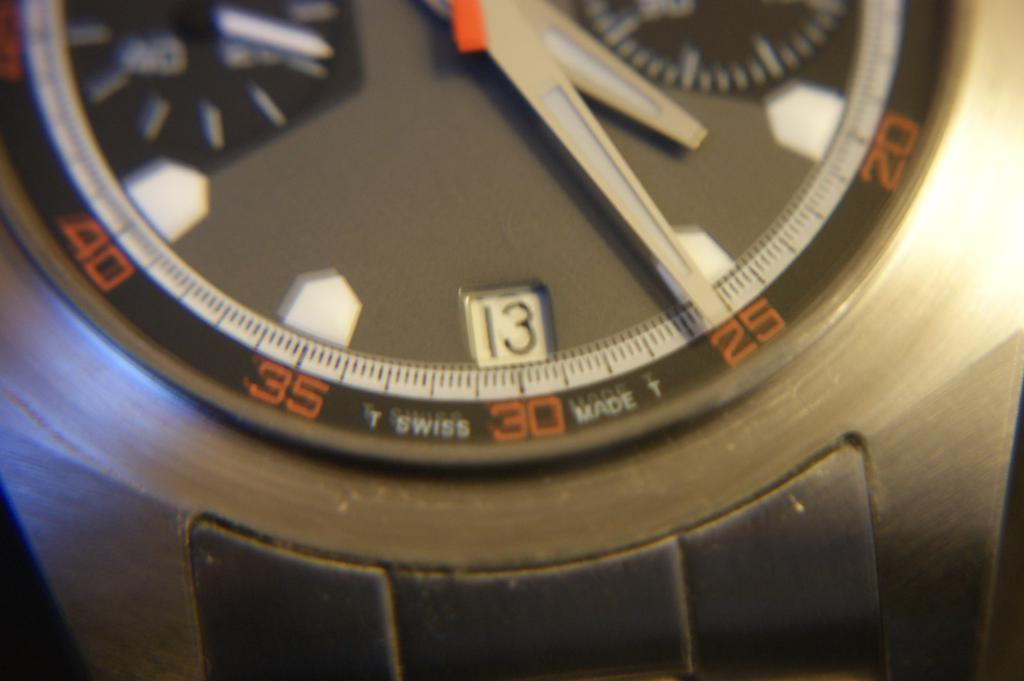Provide a one-sentence caption for the provided image. A watch that was made by T Swiss. 